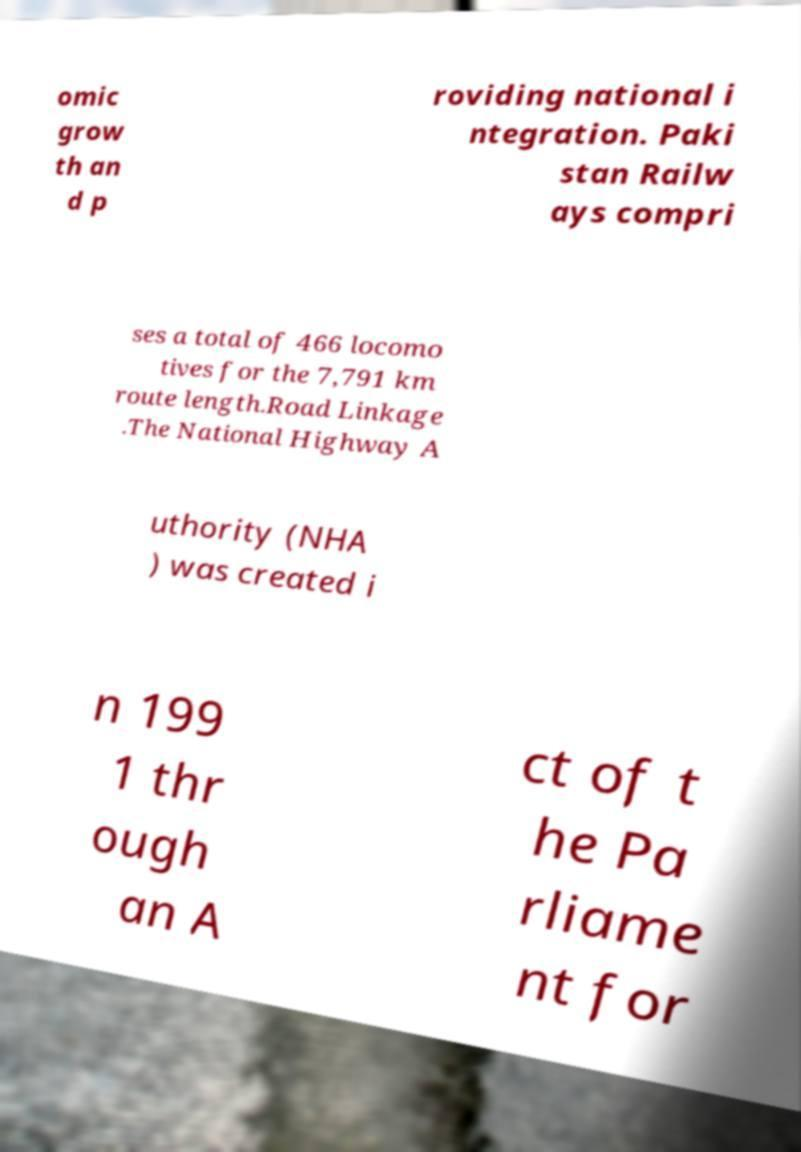There's text embedded in this image that I need extracted. Can you transcribe it verbatim? omic grow th an d p roviding national i ntegration. Paki stan Railw ays compri ses a total of 466 locomo tives for the 7,791 km route length.Road Linkage .The National Highway A uthority (NHA ) was created i n 199 1 thr ough an A ct of t he Pa rliame nt for 